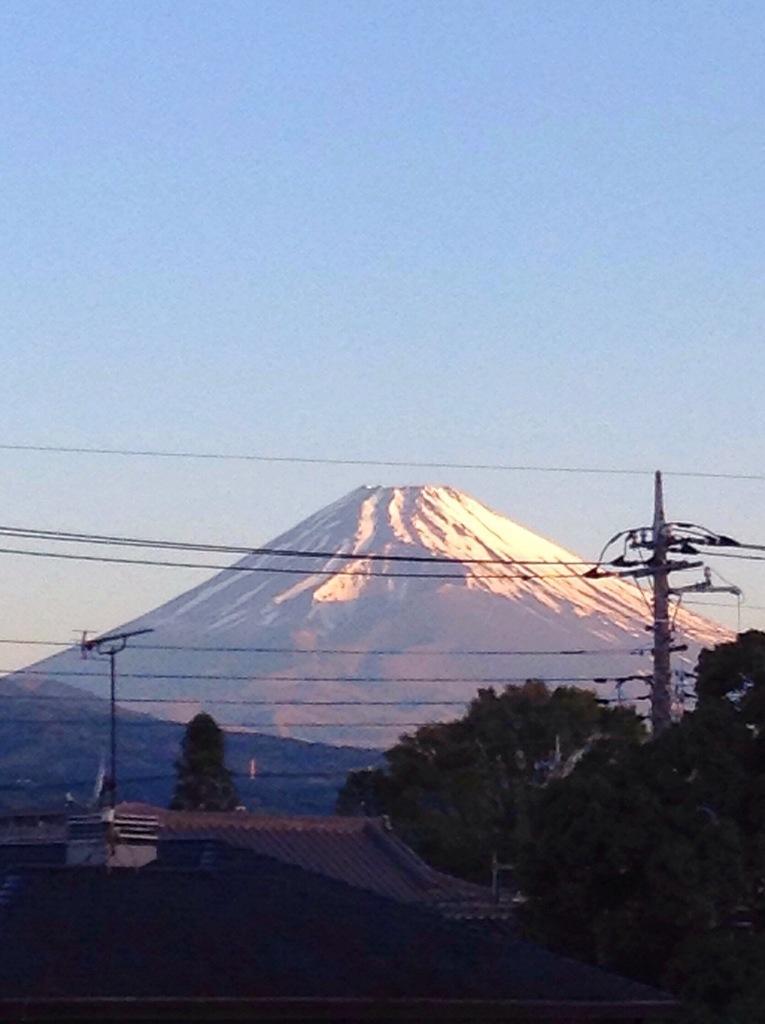How would you summarize this image in a sentence or two? In this picture we can observe buildings. There are trees and a pole on the right side. In the background we can observe a hill and a sky. 